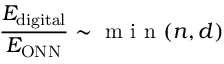<formula> <loc_0><loc_0><loc_500><loc_500>\frac { E _ { d i g i t a l } } { E _ { O N N } } \sim \min ( n , d )</formula> 